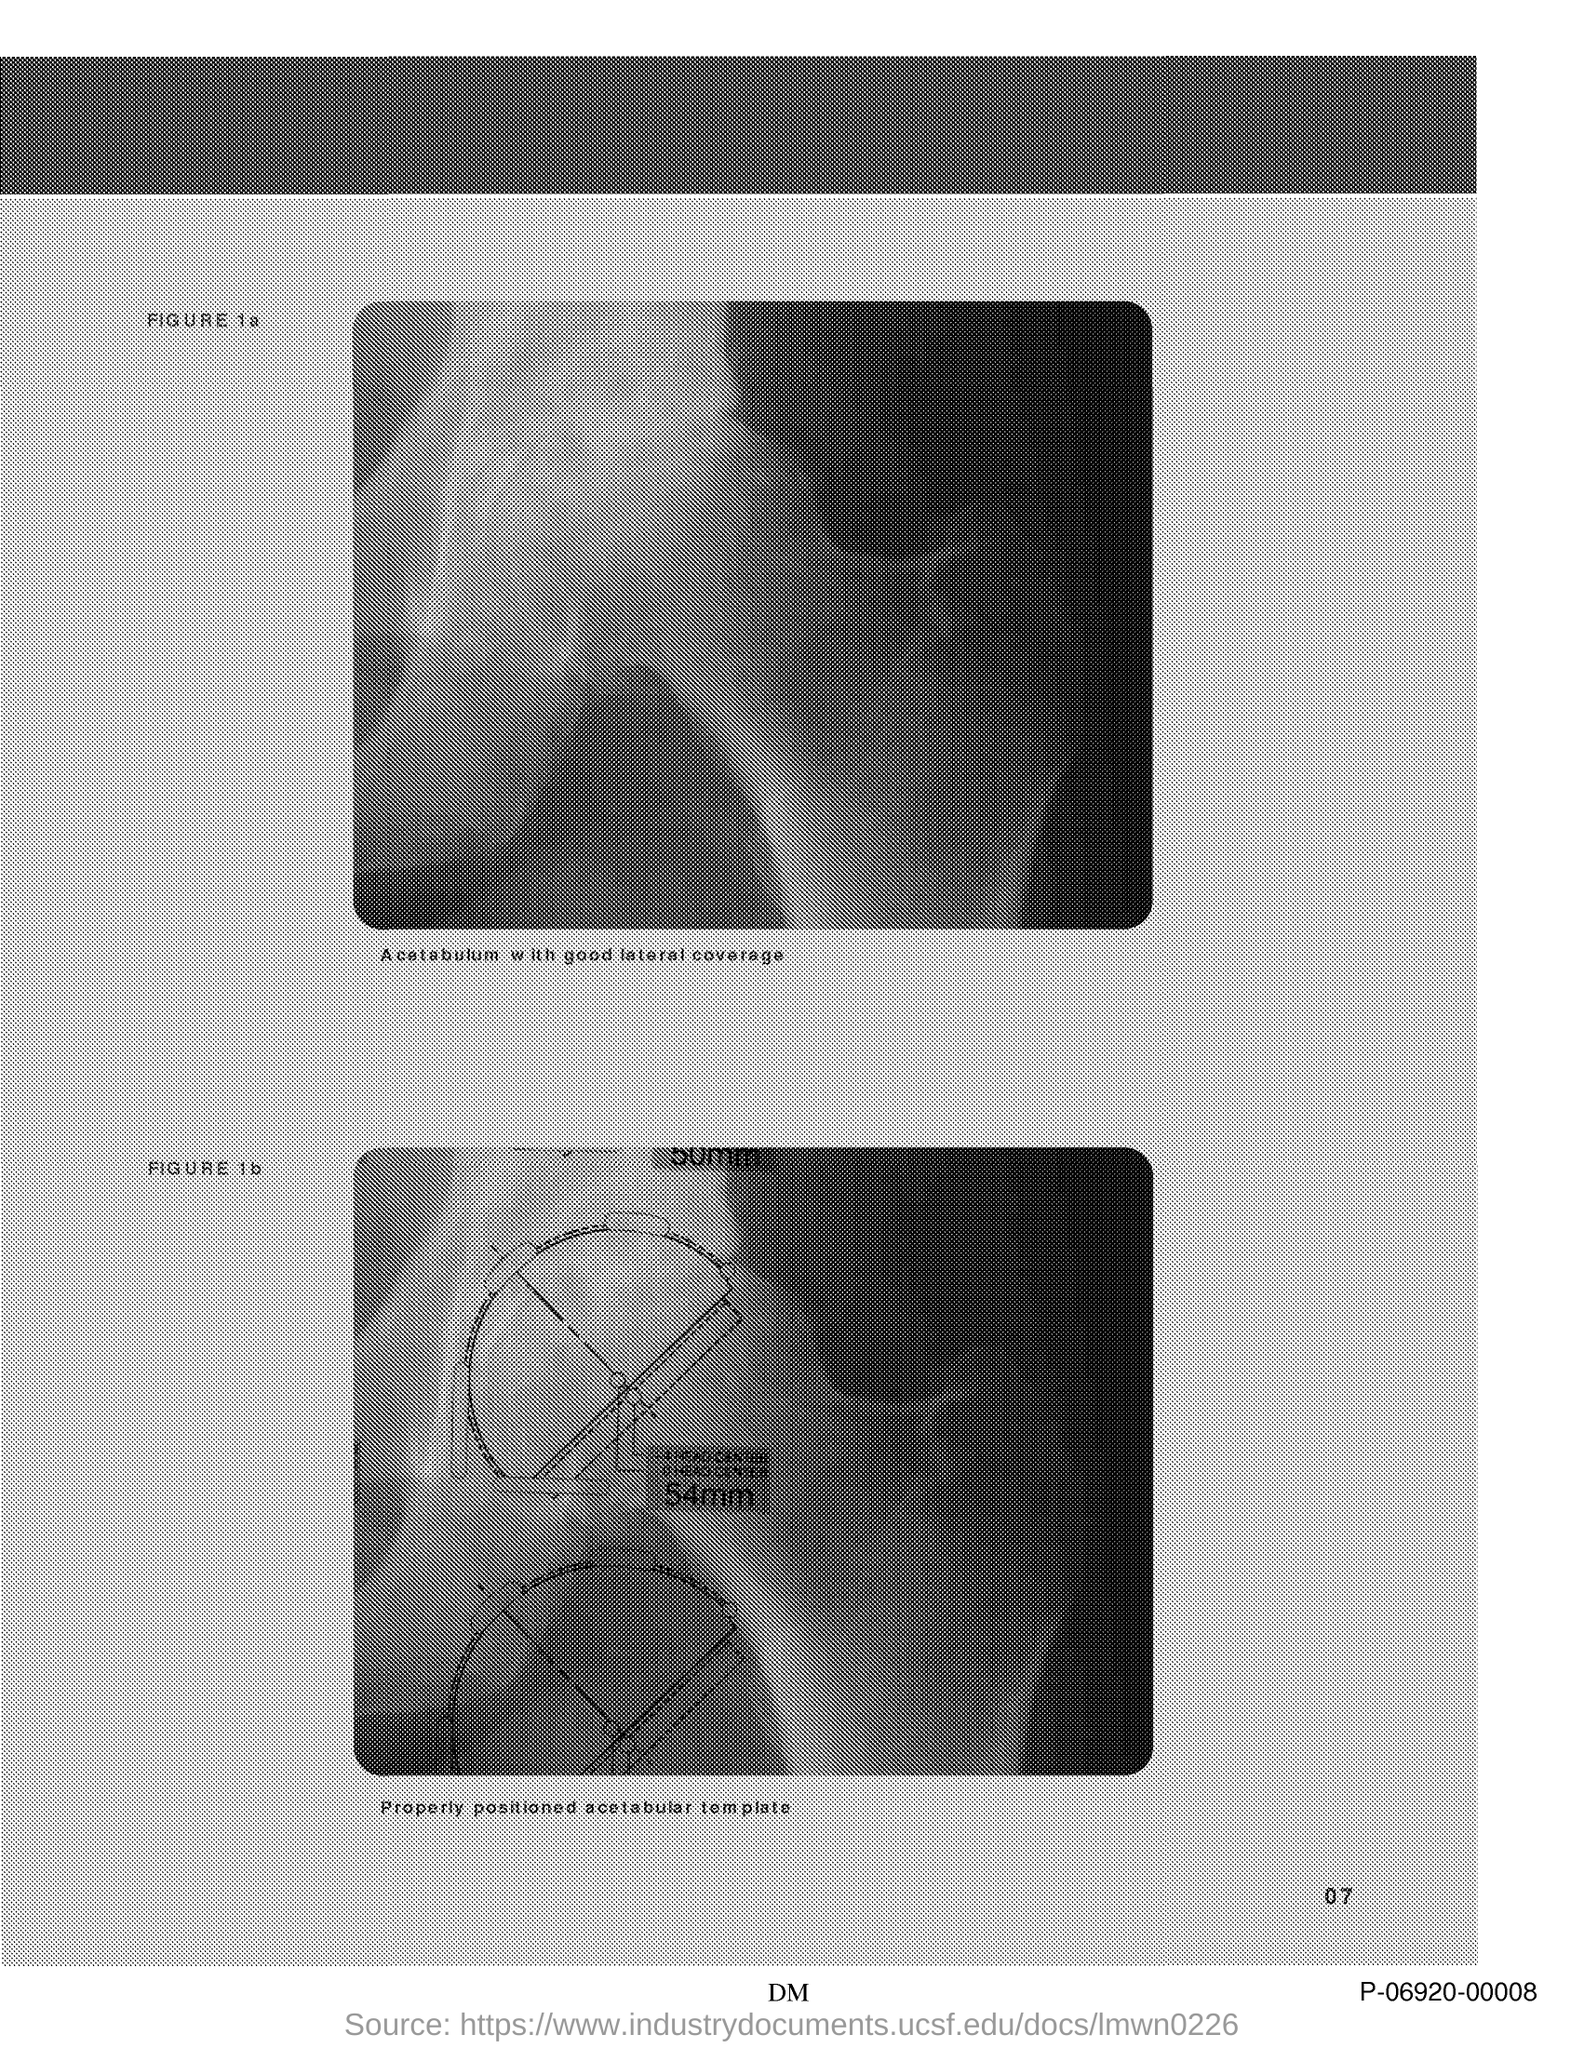Specify some key components in this picture. The text written below the first figure is "Acetabulum with good lateral coverage. 